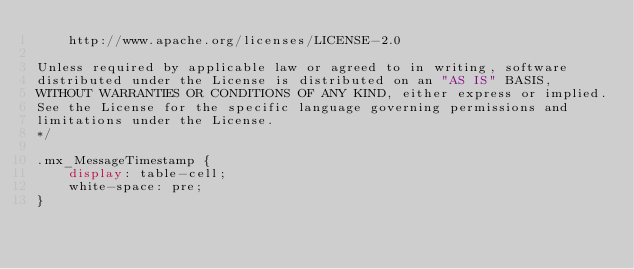<code> <loc_0><loc_0><loc_500><loc_500><_CSS_>    http://www.apache.org/licenses/LICENSE-2.0

Unless required by applicable law or agreed to in writing, software
distributed under the License is distributed on an "AS IS" BASIS,
WITHOUT WARRANTIES OR CONDITIONS OF ANY KIND, either express or implied.
See the License for the specific language governing permissions and
limitations under the License.
*/

.mx_MessageTimestamp {
    display: table-cell;
    white-space: pre;
}
</code> 